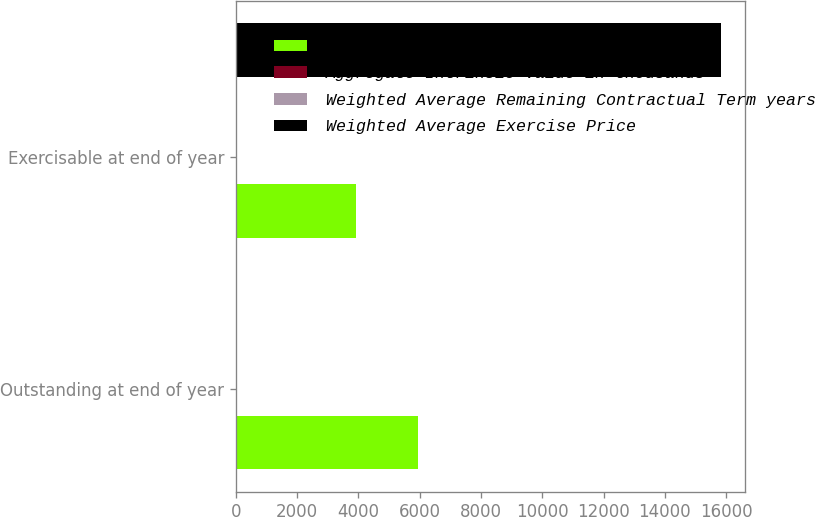Convert chart. <chart><loc_0><loc_0><loc_500><loc_500><stacked_bar_chart><ecel><fcel>Outstanding at end of year<fcel>Exercisable at end of year<nl><fcel>Options in thousands<fcel>5945<fcel>3910<nl><fcel>Aggregate Intrinsic Value in thousands<fcel>10.27<fcel>10.8<nl><fcel>Weighted Average Remaining Contractual Term years<fcel>6.3<fcel>5.18<nl><fcel>Weighted Average Exercise Price<fcel>10.8<fcel>15829<nl></chart> 